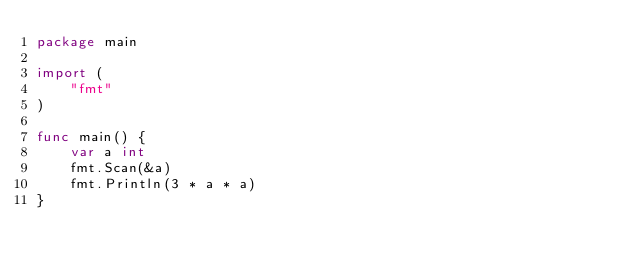<code> <loc_0><loc_0><loc_500><loc_500><_Go_>package main

import (
	"fmt"
)

func main() {
	var a int
	fmt.Scan(&a)
	fmt.Println(3 * a * a)
}
</code> 